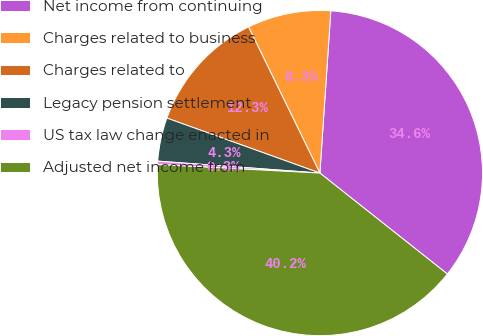Convert chart to OTSL. <chart><loc_0><loc_0><loc_500><loc_500><pie_chart><fcel>Net income from continuing<fcel>Charges related to business<fcel>Charges related to<fcel>Legacy pension settlement<fcel>US tax law change enacted in<fcel>Adjusted net income from<nl><fcel>34.59%<fcel>8.3%<fcel>12.28%<fcel>4.32%<fcel>0.34%<fcel>40.17%<nl></chart> 